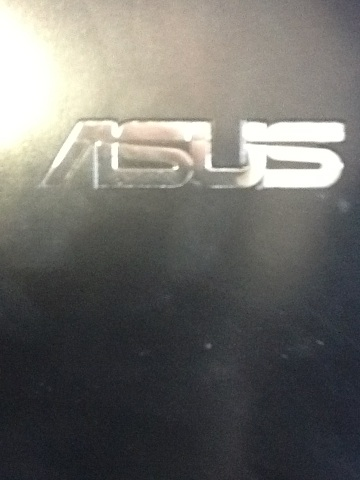What brand logo is shown in this image? The logo shown in the image is for Asus, a well-known company that manufactures laptops, smartphones, and other electronic devices. 